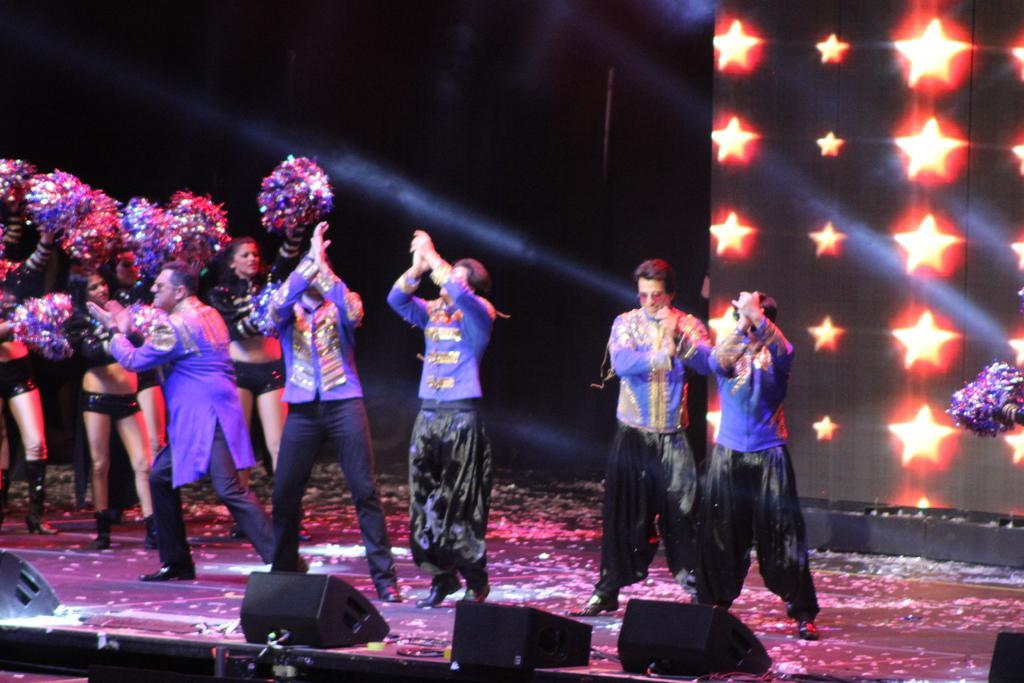In one or two sentences, can you explain what this image depicts? In this image, I can see group of people dancing on the stage. I think these are the speakers, which are black in color. This looks like a screen. I can see group of women holding pom poms in their hands. 